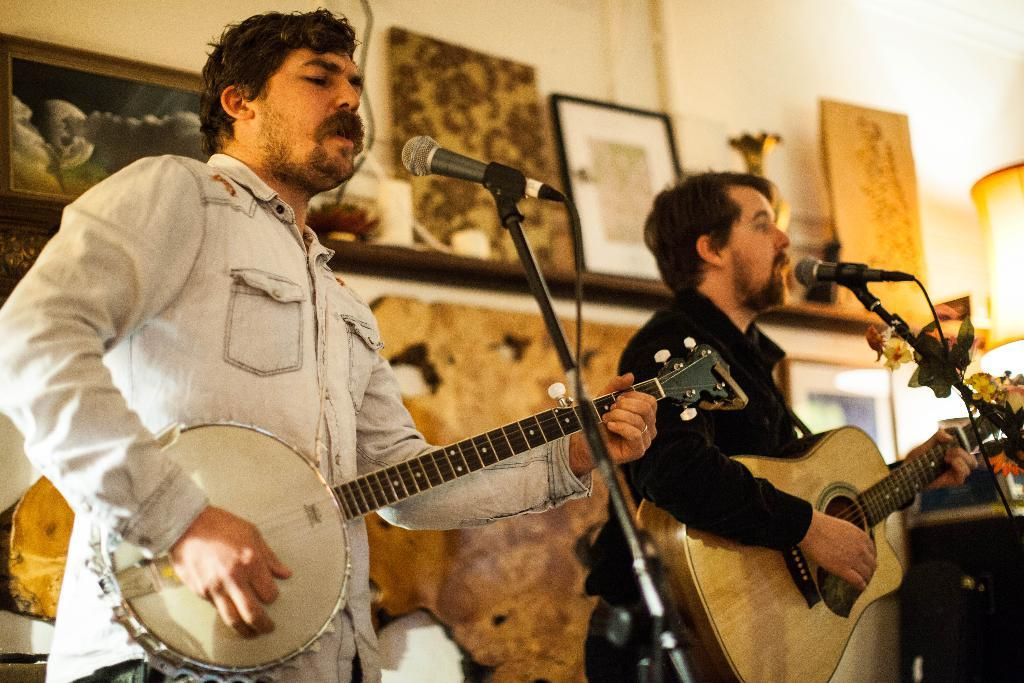How many people are in the image? There are two persons in the image. What are the two persons doing? One person is playing the guitar, and the other person is singing. What equipment is present for the singer? There is a microphone and a microphone stand in the image. What can be seen in the background of the image? There is a wall in the background of the image, and there are photo frames on the wall. Can you tell me how many teeth the person playing the guitar has in the image? It is not possible to determine the number of teeth the person playing the guitar has from the image. 